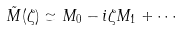Convert formula to latex. <formula><loc_0><loc_0><loc_500><loc_500>\tilde { M } ( \zeta ) \simeq M _ { 0 } - i \zeta M _ { 1 } + \cdots</formula> 